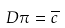Convert formula to latex. <formula><loc_0><loc_0><loc_500><loc_500>D \pi = \overline { c }</formula> 